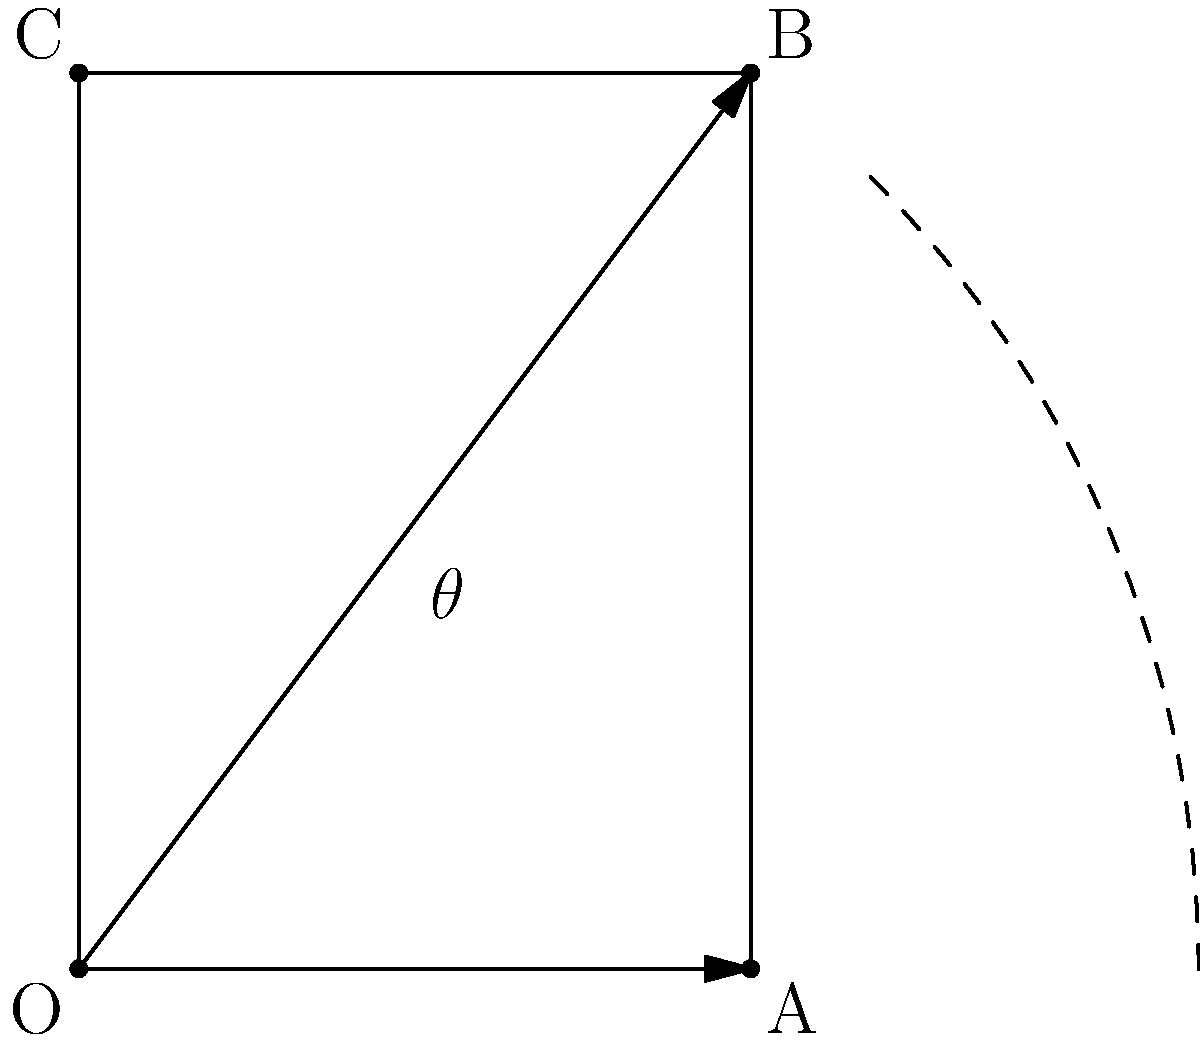A curator wants to tattoo a rectangular painting on their curved upper arm. The painting measures 3 cm by 4 cm, and the arm's circumference at that point is 10π cm. What angle of rotation (in degrees) is needed to align the painting perfectly around the arm? To solve this problem, we need to follow these steps:

1) First, we need to calculate the arc length that the painting will cover on the arm. This is equal to the diagonal of the rectangular painting.

2) The diagonal can be calculated using the Pythagorean theorem:
   $$\text{diagonal} = \sqrt{3^2 + 4^2} = \sqrt{9 + 16} = \sqrt{25} = 5 \text{ cm}$$

3) Now, we need to set up a proportion. The full circumference of the arm (10π cm) corresponds to a full rotation (360°). The diagonal of the painting (5 cm) corresponds to the angle we're looking for (θ).

   $$\frac{10\pi}{360°} = \frac{5}{\theta}$$

4) Cross multiply:
   $$10\pi\theta = 5 \cdot 360°$$

5) Solve for θ:
   $$\theta = \frac{5 \cdot 360°}{10\pi} = \frac{1800°}{10\pi} = \frac{180°}{\pi}$$

6) Calculate the final result:
   $$\theta \approx 57.3°$$

Therefore, the painting needs to be rotated approximately 57.3° to align perfectly around the arm.
Answer: 57.3° 